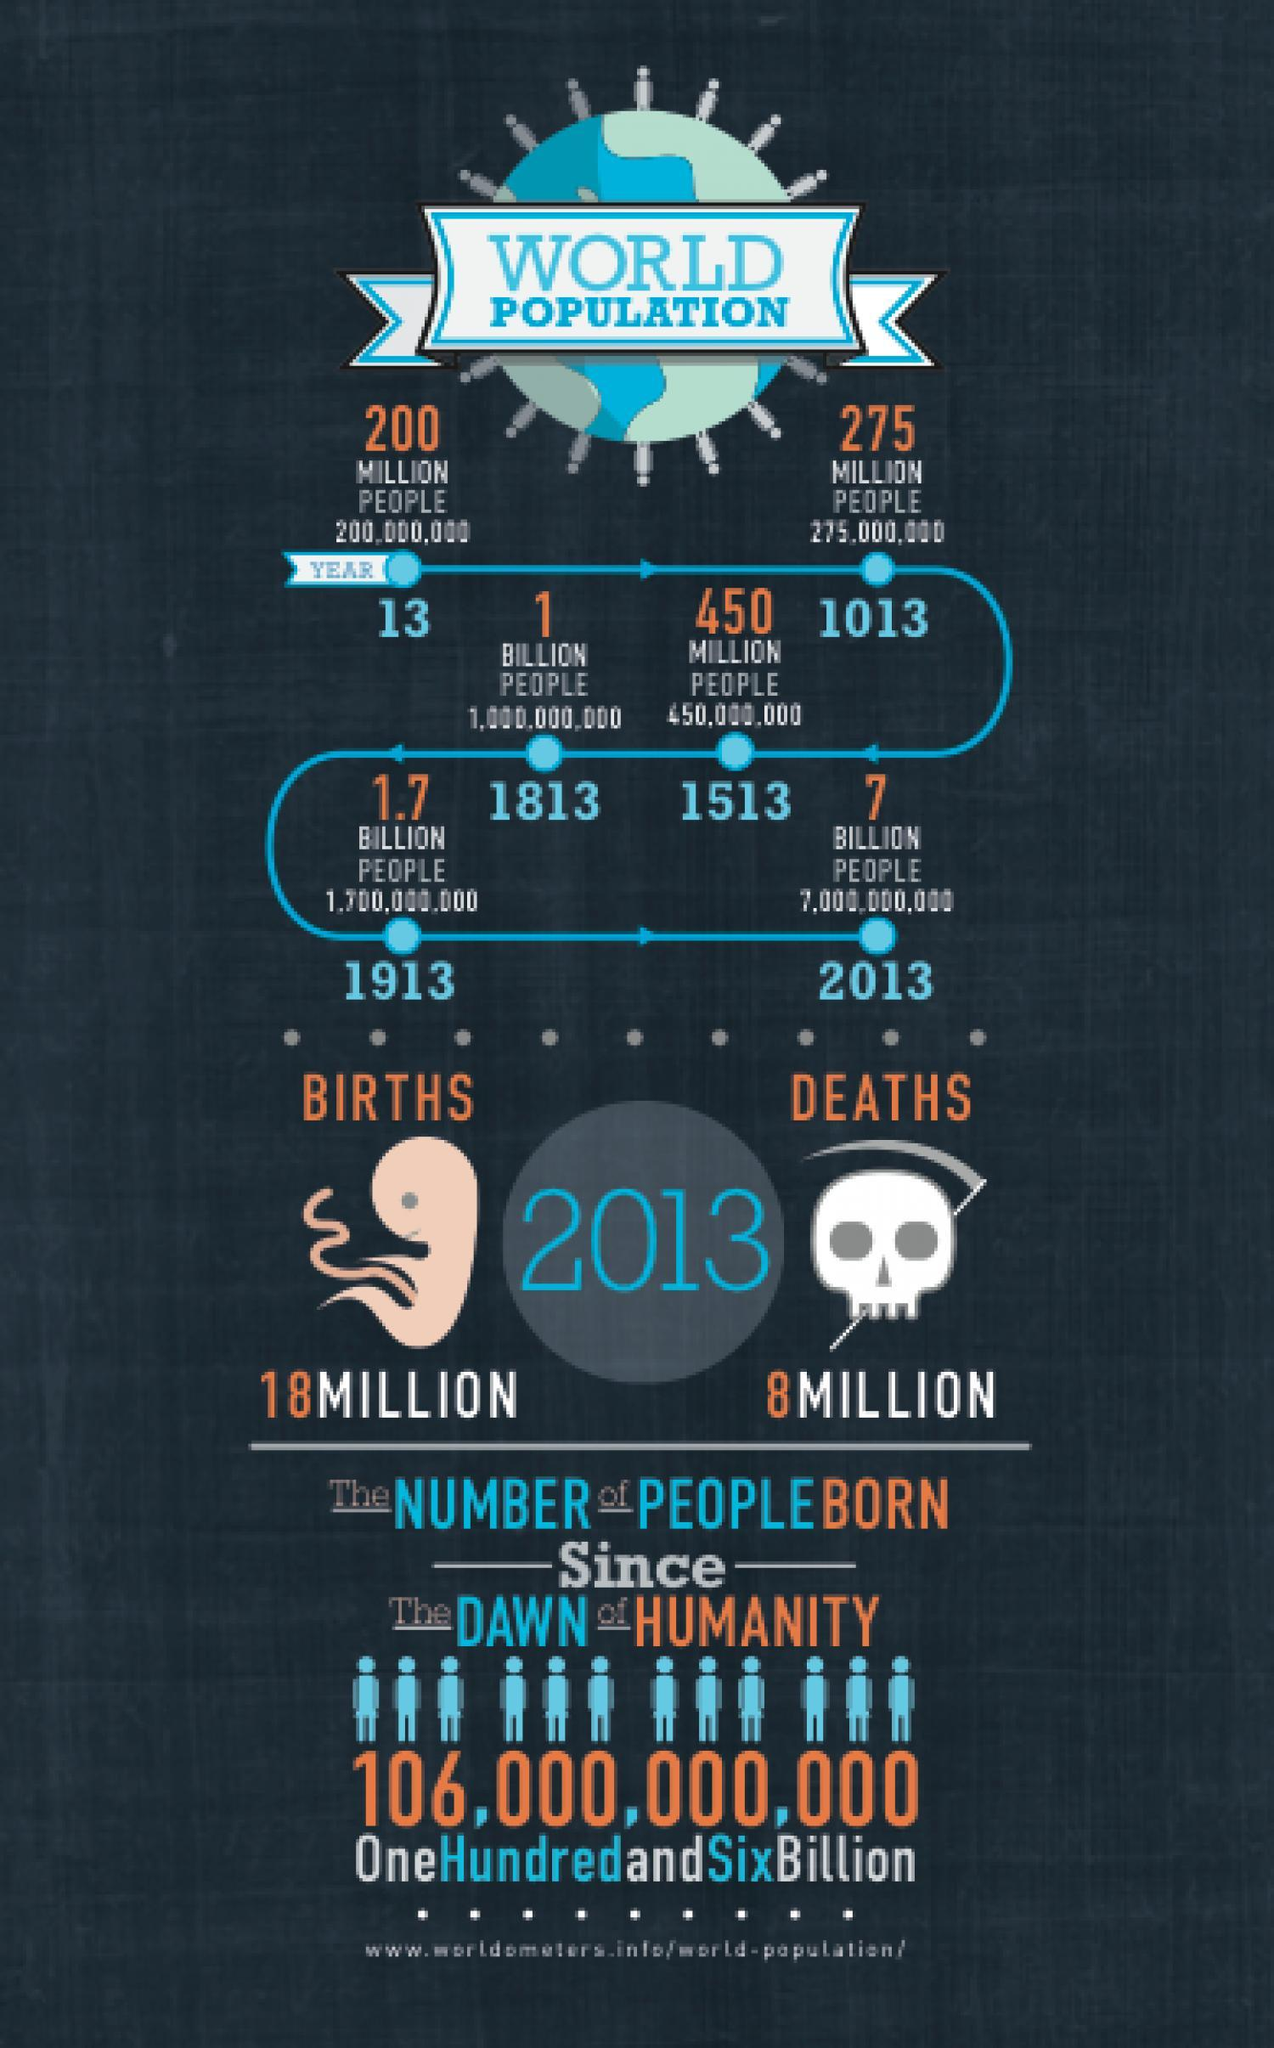What is the difference between births and deaths in 2013?
Answer the question with a short phrase. 10Million 